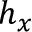<formula> <loc_0><loc_0><loc_500><loc_500>h _ { x }</formula> 